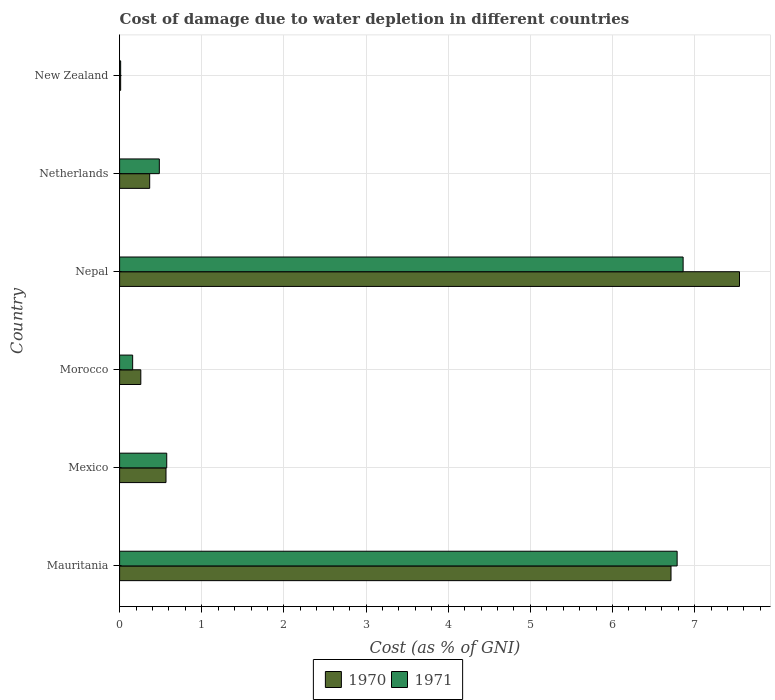Are the number of bars on each tick of the Y-axis equal?
Your answer should be very brief. Yes. How many bars are there on the 1st tick from the top?
Offer a terse response. 2. How many bars are there on the 5th tick from the bottom?
Keep it short and to the point. 2. What is the label of the 1st group of bars from the top?
Provide a short and direct response. New Zealand. What is the cost of damage caused due to water depletion in 1970 in Nepal?
Provide a succinct answer. 7.55. Across all countries, what is the maximum cost of damage caused due to water depletion in 1971?
Your answer should be very brief. 6.86. Across all countries, what is the minimum cost of damage caused due to water depletion in 1970?
Your answer should be compact. 0.01. In which country was the cost of damage caused due to water depletion in 1971 maximum?
Provide a short and direct response. Nepal. In which country was the cost of damage caused due to water depletion in 1971 minimum?
Your answer should be compact. New Zealand. What is the total cost of damage caused due to water depletion in 1970 in the graph?
Make the answer very short. 15.46. What is the difference between the cost of damage caused due to water depletion in 1971 in Mauritania and that in Mexico?
Your response must be concise. 6.21. What is the difference between the cost of damage caused due to water depletion in 1971 in New Zealand and the cost of damage caused due to water depletion in 1970 in Morocco?
Make the answer very short. -0.25. What is the average cost of damage caused due to water depletion in 1971 per country?
Your answer should be compact. 2.48. What is the difference between the cost of damage caused due to water depletion in 1970 and cost of damage caused due to water depletion in 1971 in Nepal?
Make the answer very short. 0.69. In how many countries, is the cost of damage caused due to water depletion in 1971 greater than 5.2 %?
Ensure brevity in your answer.  2. What is the ratio of the cost of damage caused due to water depletion in 1971 in Morocco to that in Nepal?
Your answer should be very brief. 0.02. Is the cost of damage caused due to water depletion in 1971 in Mexico less than that in Netherlands?
Your answer should be compact. No. What is the difference between the highest and the second highest cost of damage caused due to water depletion in 1971?
Make the answer very short. 0.07. What is the difference between the highest and the lowest cost of damage caused due to water depletion in 1970?
Ensure brevity in your answer.  7.53. How many bars are there?
Provide a short and direct response. 12. What is the difference between two consecutive major ticks on the X-axis?
Keep it short and to the point. 1. Are the values on the major ticks of X-axis written in scientific E-notation?
Your answer should be very brief. No. Does the graph contain any zero values?
Your response must be concise. No. Does the graph contain grids?
Your answer should be compact. Yes. Where does the legend appear in the graph?
Your answer should be very brief. Bottom center. What is the title of the graph?
Make the answer very short. Cost of damage due to water depletion in different countries. Does "1968" appear as one of the legend labels in the graph?
Provide a succinct answer. No. What is the label or title of the X-axis?
Your response must be concise. Cost (as % of GNI). What is the Cost (as % of GNI) in 1970 in Mauritania?
Your response must be concise. 6.71. What is the Cost (as % of GNI) of 1971 in Mauritania?
Keep it short and to the point. 6.79. What is the Cost (as % of GNI) of 1970 in Mexico?
Your response must be concise. 0.56. What is the Cost (as % of GNI) in 1971 in Mexico?
Offer a terse response. 0.57. What is the Cost (as % of GNI) of 1970 in Morocco?
Provide a short and direct response. 0.26. What is the Cost (as % of GNI) of 1971 in Morocco?
Make the answer very short. 0.16. What is the Cost (as % of GNI) of 1970 in Nepal?
Your answer should be very brief. 7.55. What is the Cost (as % of GNI) of 1971 in Nepal?
Your answer should be compact. 6.86. What is the Cost (as % of GNI) of 1970 in Netherlands?
Your answer should be very brief. 0.37. What is the Cost (as % of GNI) in 1971 in Netherlands?
Provide a short and direct response. 0.48. What is the Cost (as % of GNI) in 1970 in New Zealand?
Provide a succinct answer. 0.01. What is the Cost (as % of GNI) in 1971 in New Zealand?
Provide a succinct answer. 0.01. Across all countries, what is the maximum Cost (as % of GNI) of 1970?
Make the answer very short. 7.55. Across all countries, what is the maximum Cost (as % of GNI) of 1971?
Offer a terse response. 6.86. Across all countries, what is the minimum Cost (as % of GNI) of 1970?
Your answer should be very brief. 0.01. Across all countries, what is the minimum Cost (as % of GNI) of 1971?
Keep it short and to the point. 0.01. What is the total Cost (as % of GNI) of 1970 in the graph?
Ensure brevity in your answer.  15.46. What is the total Cost (as % of GNI) of 1971 in the graph?
Give a very brief answer. 14.88. What is the difference between the Cost (as % of GNI) in 1970 in Mauritania and that in Mexico?
Provide a short and direct response. 6.15. What is the difference between the Cost (as % of GNI) in 1971 in Mauritania and that in Mexico?
Your answer should be very brief. 6.21. What is the difference between the Cost (as % of GNI) of 1970 in Mauritania and that in Morocco?
Provide a succinct answer. 6.45. What is the difference between the Cost (as % of GNI) in 1971 in Mauritania and that in Morocco?
Offer a terse response. 6.63. What is the difference between the Cost (as % of GNI) of 1970 in Mauritania and that in Nepal?
Keep it short and to the point. -0.83. What is the difference between the Cost (as % of GNI) of 1971 in Mauritania and that in Nepal?
Make the answer very short. -0.07. What is the difference between the Cost (as % of GNI) of 1970 in Mauritania and that in Netherlands?
Offer a very short reply. 6.35. What is the difference between the Cost (as % of GNI) in 1971 in Mauritania and that in Netherlands?
Your answer should be very brief. 6.3. What is the difference between the Cost (as % of GNI) in 1970 in Mauritania and that in New Zealand?
Provide a short and direct response. 6.7. What is the difference between the Cost (as % of GNI) of 1971 in Mauritania and that in New Zealand?
Your response must be concise. 6.77. What is the difference between the Cost (as % of GNI) of 1970 in Mexico and that in Morocco?
Ensure brevity in your answer.  0.31. What is the difference between the Cost (as % of GNI) in 1971 in Mexico and that in Morocco?
Offer a terse response. 0.41. What is the difference between the Cost (as % of GNI) in 1970 in Mexico and that in Nepal?
Provide a short and direct response. -6.98. What is the difference between the Cost (as % of GNI) in 1971 in Mexico and that in Nepal?
Provide a succinct answer. -6.29. What is the difference between the Cost (as % of GNI) in 1970 in Mexico and that in Netherlands?
Keep it short and to the point. 0.2. What is the difference between the Cost (as % of GNI) in 1971 in Mexico and that in Netherlands?
Your response must be concise. 0.09. What is the difference between the Cost (as % of GNI) in 1970 in Mexico and that in New Zealand?
Your response must be concise. 0.55. What is the difference between the Cost (as % of GNI) in 1971 in Mexico and that in New Zealand?
Give a very brief answer. 0.56. What is the difference between the Cost (as % of GNI) of 1970 in Morocco and that in Nepal?
Give a very brief answer. -7.29. What is the difference between the Cost (as % of GNI) in 1971 in Morocco and that in Nepal?
Make the answer very short. -6.7. What is the difference between the Cost (as % of GNI) of 1970 in Morocco and that in Netherlands?
Ensure brevity in your answer.  -0.11. What is the difference between the Cost (as % of GNI) of 1971 in Morocco and that in Netherlands?
Your answer should be very brief. -0.32. What is the difference between the Cost (as % of GNI) of 1970 in Morocco and that in New Zealand?
Provide a short and direct response. 0.25. What is the difference between the Cost (as % of GNI) in 1971 in Morocco and that in New Zealand?
Provide a short and direct response. 0.15. What is the difference between the Cost (as % of GNI) in 1970 in Nepal and that in Netherlands?
Make the answer very short. 7.18. What is the difference between the Cost (as % of GNI) in 1971 in Nepal and that in Netherlands?
Your answer should be compact. 6.38. What is the difference between the Cost (as % of GNI) of 1970 in Nepal and that in New Zealand?
Provide a succinct answer. 7.53. What is the difference between the Cost (as % of GNI) in 1971 in Nepal and that in New Zealand?
Offer a terse response. 6.85. What is the difference between the Cost (as % of GNI) in 1970 in Netherlands and that in New Zealand?
Offer a very short reply. 0.35. What is the difference between the Cost (as % of GNI) in 1971 in Netherlands and that in New Zealand?
Your response must be concise. 0.47. What is the difference between the Cost (as % of GNI) in 1970 in Mauritania and the Cost (as % of GNI) in 1971 in Mexico?
Your answer should be compact. 6.14. What is the difference between the Cost (as % of GNI) in 1970 in Mauritania and the Cost (as % of GNI) in 1971 in Morocco?
Offer a terse response. 6.55. What is the difference between the Cost (as % of GNI) in 1970 in Mauritania and the Cost (as % of GNI) in 1971 in Nepal?
Offer a very short reply. -0.15. What is the difference between the Cost (as % of GNI) in 1970 in Mauritania and the Cost (as % of GNI) in 1971 in Netherlands?
Ensure brevity in your answer.  6.23. What is the difference between the Cost (as % of GNI) in 1970 in Mauritania and the Cost (as % of GNI) in 1971 in New Zealand?
Give a very brief answer. 6.7. What is the difference between the Cost (as % of GNI) in 1970 in Mexico and the Cost (as % of GNI) in 1971 in Morocco?
Ensure brevity in your answer.  0.41. What is the difference between the Cost (as % of GNI) of 1970 in Mexico and the Cost (as % of GNI) of 1971 in Nepal?
Your answer should be very brief. -6.3. What is the difference between the Cost (as % of GNI) of 1970 in Mexico and the Cost (as % of GNI) of 1971 in Netherlands?
Give a very brief answer. 0.08. What is the difference between the Cost (as % of GNI) in 1970 in Mexico and the Cost (as % of GNI) in 1971 in New Zealand?
Give a very brief answer. 0.55. What is the difference between the Cost (as % of GNI) in 1970 in Morocco and the Cost (as % of GNI) in 1971 in Nepal?
Your response must be concise. -6.6. What is the difference between the Cost (as % of GNI) in 1970 in Morocco and the Cost (as % of GNI) in 1971 in Netherlands?
Offer a terse response. -0.23. What is the difference between the Cost (as % of GNI) in 1970 in Morocco and the Cost (as % of GNI) in 1971 in New Zealand?
Your answer should be very brief. 0.25. What is the difference between the Cost (as % of GNI) in 1970 in Nepal and the Cost (as % of GNI) in 1971 in Netherlands?
Provide a short and direct response. 7.06. What is the difference between the Cost (as % of GNI) of 1970 in Nepal and the Cost (as % of GNI) of 1971 in New Zealand?
Provide a short and direct response. 7.53. What is the difference between the Cost (as % of GNI) of 1970 in Netherlands and the Cost (as % of GNI) of 1971 in New Zealand?
Your answer should be very brief. 0.35. What is the average Cost (as % of GNI) of 1970 per country?
Give a very brief answer. 2.58. What is the average Cost (as % of GNI) of 1971 per country?
Make the answer very short. 2.48. What is the difference between the Cost (as % of GNI) of 1970 and Cost (as % of GNI) of 1971 in Mauritania?
Your answer should be compact. -0.07. What is the difference between the Cost (as % of GNI) of 1970 and Cost (as % of GNI) of 1971 in Mexico?
Provide a short and direct response. -0.01. What is the difference between the Cost (as % of GNI) in 1970 and Cost (as % of GNI) in 1971 in Morocco?
Ensure brevity in your answer.  0.1. What is the difference between the Cost (as % of GNI) in 1970 and Cost (as % of GNI) in 1971 in Nepal?
Give a very brief answer. 0.69. What is the difference between the Cost (as % of GNI) of 1970 and Cost (as % of GNI) of 1971 in Netherlands?
Provide a short and direct response. -0.12. What is the difference between the Cost (as % of GNI) of 1970 and Cost (as % of GNI) of 1971 in New Zealand?
Your answer should be compact. -0. What is the ratio of the Cost (as % of GNI) of 1970 in Mauritania to that in Mexico?
Keep it short and to the point. 11.89. What is the ratio of the Cost (as % of GNI) in 1971 in Mauritania to that in Mexico?
Keep it short and to the point. 11.83. What is the ratio of the Cost (as % of GNI) in 1970 in Mauritania to that in Morocco?
Provide a succinct answer. 26. What is the ratio of the Cost (as % of GNI) in 1971 in Mauritania to that in Morocco?
Give a very brief answer. 42.73. What is the ratio of the Cost (as % of GNI) of 1970 in Mauritania to that in Nepal?
Ensure brevity in your answer.  0.89. What is the ratio of the Cost (as % of GNI) of 1970 in Mauritania to that in Netherlands?
Offer a terse response. 18.33. What is the ratio of the Cost (as % of GNI) of 1971 in Mauritania to that in Netherlands?
Offer a very short reply. 14.04. What is the ratio of the Cost (as % of GNI) in 1970 in Mauritania to that in New Zealand?
Offer a terse response. 522.66. What is the ratio of the Cost (as % of GNI) in 1971 in Mauritania to that in New Zealand?
Offer a terse response. 526.42. What is the ratio of the Cost (as % of GNI) in 1970 in Mexico to that in Morocco?
Your answer should be compact. 2.19. What is the ratio of the Cost (as % of GNI) in 1971 in Mexico to that in Morocco?
Make the answer very short. 3.61. What is the ratio of the Cost (as % of GNI) in 1970 in Mexico to that in Nepal?
Give a very brief answer. 0.07. What is the ratio of the Cost (as % of GNI) of 1971 in Mexico to that in Nepal?
Ensure brevity in your answer.  0.08. What is the ratio of the Cost (as % of GNI) of 1970 in Mexico to that in Netherlands?
Offer a terse response. 1.54. What is the ratio of the Cost (as % of GNI) of 1971 in Mexico to that in Netherlands?
Make the answer very short. 1.19. What is the ratio of the Cost (as % of GNI) in 1970 in Mexico to that in New Zealand?
Offer a very short reply. 43.97. What is the ratio of the Cost (as % of GNI) in 1971 in Mexico to that in New Zealand?
Your answer should be very brief. 44.51. What is the ratio of the Cost (as % of GNI) in 1970 in Morocco to that in Nepal?
Make the answer very short. 0.03. What is the ratio of the Cost (as % of GNI) of 1971 in Morocco to that in Nepal?
Make the answer very short. 0.02. What is the ratio of the Cost (as % of GNI) of 1970 in Morocco to that in Netherlands?
Your answer should be compact. 0.7. What is the ratio of the Cost (as % of GNI) of 1971 in Morocco to that in Netherlands?
Your response must be concise. 0.33. What is the ratio of the Cost (as % of GNI) of 1970 in Morocco to that in New Zealand?
Make the answer very short. 20.1. What is the ratio of the Cost (as % of GNI) of 1971 in Morocco to that in New Zealand?
Your response must be concise. 12.32. What is the ratio of the Cost (as % of GNI) of 1970 in Nepal to that in Netherlands?
Provide a short and direct response. 20.6. What is the ratio of the Cost (as % of GNI) of 1971 in Nepal to that in Netherlands?
Your answer should be compact. 14.19. What is the ratio of the Cost (as % of GNI) in 1970 in Nepal to that in New Zealand?
Your answer should be compact. 587.57. What is the ratio of the Cost (as % of GNI) of 1971 in Nepal to that in New Zealand?
Provide a short and direct response. 532.07. What is the ratio of the Cost (as % of GNI) in 1970 in Netherlands to that in New Zealand?
Provide a succinct answer. 28.52. What is the ratio of the Cost (as % of GNI) in 1971 in Netherlands to that in New Zealand?
Ensure brevity in your answer.  37.51. What is the difference between the highest and the second highest Cost (as % of GNI) of 1970?
Offer a very short reply. 0.83. What is the difference between the highest and the second highest Cost (as % of GNI) of 1971?
Keep it short and to the point. 0.07. What is the difference between the highest and the lowest Cost (as % of GNI) of 1970?
Your response must be concise. 7.53. What is the difference between the highest and the lowest Cost (as % of GNI) of 1971?
Provide a short and direct response. 6.85. 